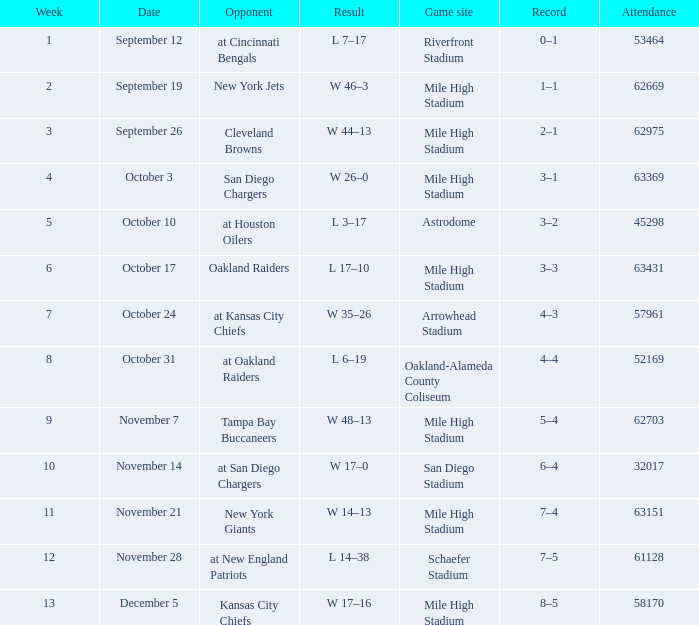What was the date of the week 4 game? October 3. 